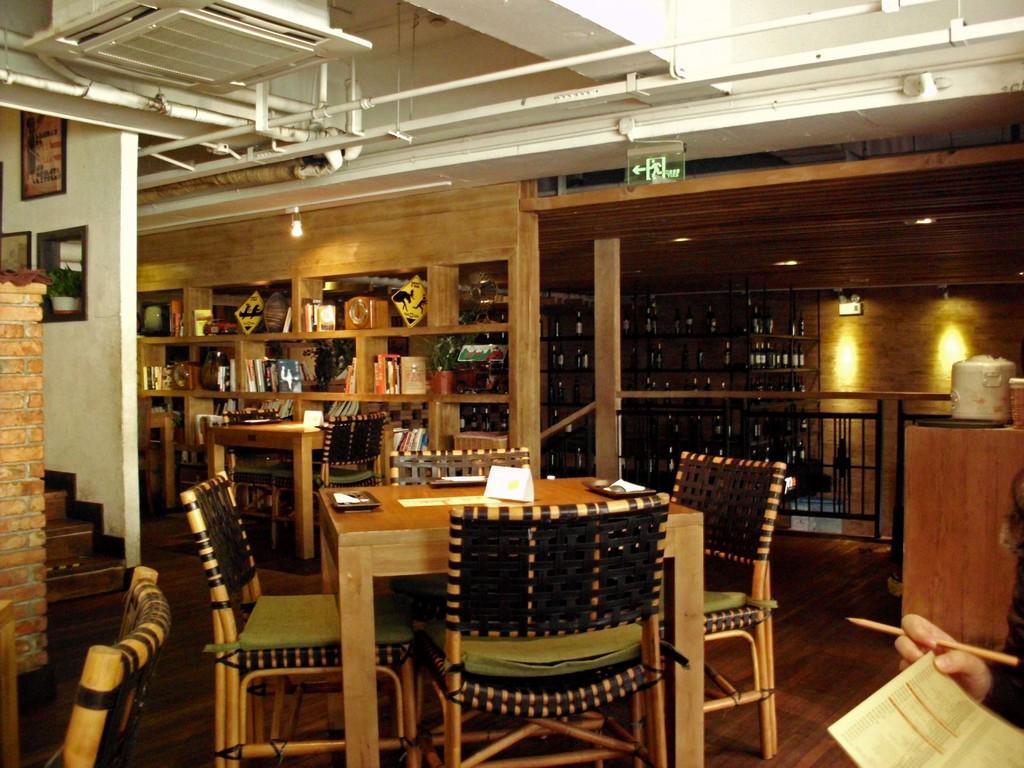Please provide a concise description of this image. At the bottom right side of the image, we can see one human hand holding one pen and a paper. In the center of the image we can see one table and chairs. On the table, we can see plates, papers and a few other objects. At the bottom left side of the image, we can see one chair and one wooden object. In the background there is a wall, tables, chairs, shelves, books, lights, one sign board, photo frames, one plant pot, plant, banners, wine bottles, fences, one pillar, staircase and a few other objects. 